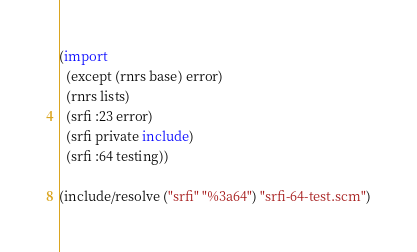<code> <loc_0><loc_0><loc_500><loc_500><_Scheme_>(import
  (except (rnrs base) error)
  (rnrs lists)
  (srfi :23 error)
  (srfi private include)
  (srfi :64 testing))

(include/resolve ("srfi" "%3a64") "srfi-64-test.scm")
</code> 